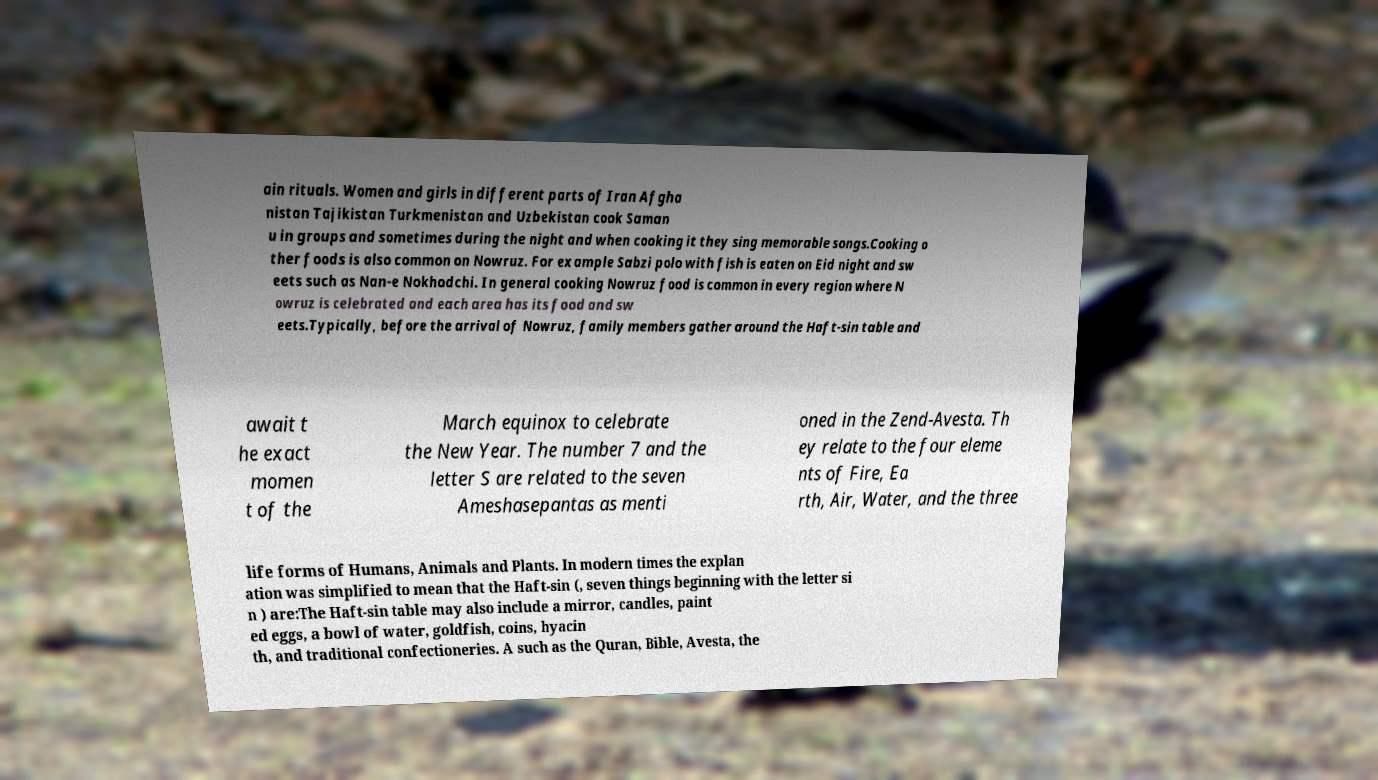For documentation purposes, I need the text within this image transcribed. Could you provide that? ain rituals. Women and girls in different parts of Iran Afgha nistan Tajikistan Turkmenistan and Uzbekistan cook Saman u in groups and sometimes during the night and when cooking it they sing memorable songs.Cooking o ther foods is also common on Nowruz. For example Sabzi polo with fish is eaten on Eid night and sw eets such as Nan-e Nokhodchi. In general cooking Nowruz food is common in every region where N owruz is celebrated and each area has its food and sw eets.Typically, before the arrival of Nowruz, family members gather around the Haft-sin table and await t he exact momen t of the March equinox to celebrate the New Year. The number 7 and the letter S are related to the seven Ameshasepantas as menti oned in the Zend-Avesta. Th ey relate to the four eleme nts of Fire, Ea rth, Air, Water, and the three life forms of Humans, Animals and Plants. In modern times the explan ation was simplified to mean that the Haft-sin (, seven things beginning with the letter si n ) are:The Haft-sin table may also include a mirror, candles, paint ed eggs, a bowl of water, goldfish, coins, hyacin th, and traditional confectioneries. A such as the Quran, Bible, Avesta, the 